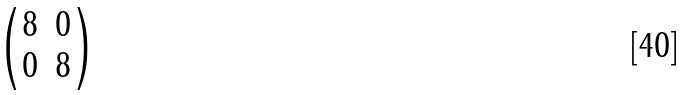<formula> <loc_0><loc_0><loc_500><loc_500>\begin{pmatrix} 8 & 0 \\ 0 & 8 \end{pmatrix}</formula> 